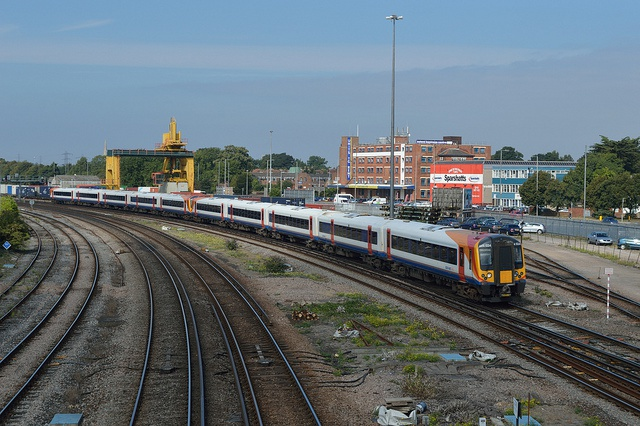Describe the objects in this image and their specific colors. I can see train in darkgray, black, gray, and navy tones, car in darkgray, gray, and black tones, car in darkgray, white, gray, and black tones, car in darkgray, black, navy, blue, and gray tones, and car in darkgray, black, blue, gray, and navy tones in this image. 